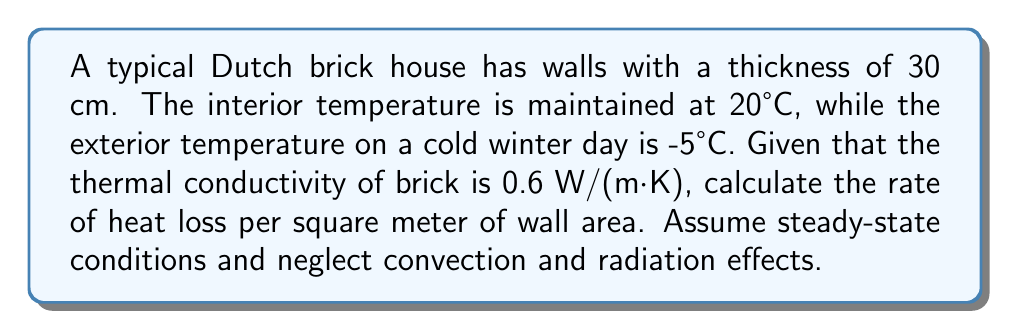Can you answer this question? To solve this problem, we'll use Fourier's law of heat conduction in one dimension:

$$q = -k \frac{dT}{dx}$$

Where:
$q$ = heat flux (W/m²)
$k$ = thermal conductivity (W/(m·K))
$\frac{dT}{dx}$ = temperature gradient (K/m)

For steady-state conditions in a plane wall, we can simplify this to:

$$q = k \frac{T_2 - T_1}{L}$$

Where:
$T_2$ = interior temperature (K)
$T_1$ = exterior temperature (K)
$L$ = wall thickness (m)

Step 1: Convert temperatures to Kelvin
$T_2 = 20°C + 273.15 = 293.15 K$
$T_1 = -5°C + 273.15 = 268.15 K$

Step 2: Substitute values into the equation
$q = 0.6 \frac{293.15 - 268.15}{0.30}$

Step 3: Calculate the heat flux
$q = 0.6 \frac{25}{0.30} = 50 \text{ W/m²}$

The negative sign is omitted as we're interested in the magnitude of heat loss.
Answer: 50 W/m² 